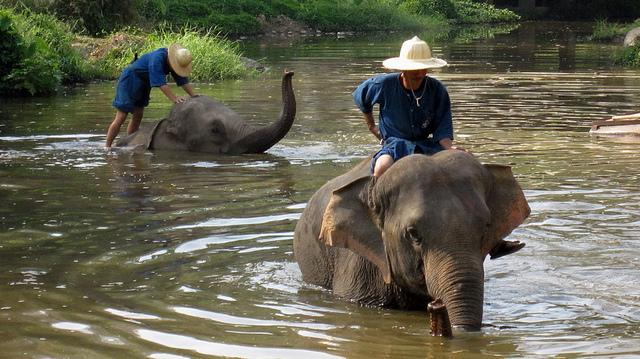What are the hats the men are wearing called? sun hat 